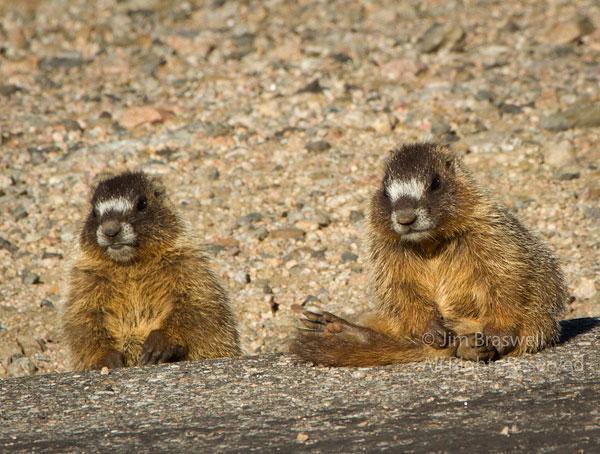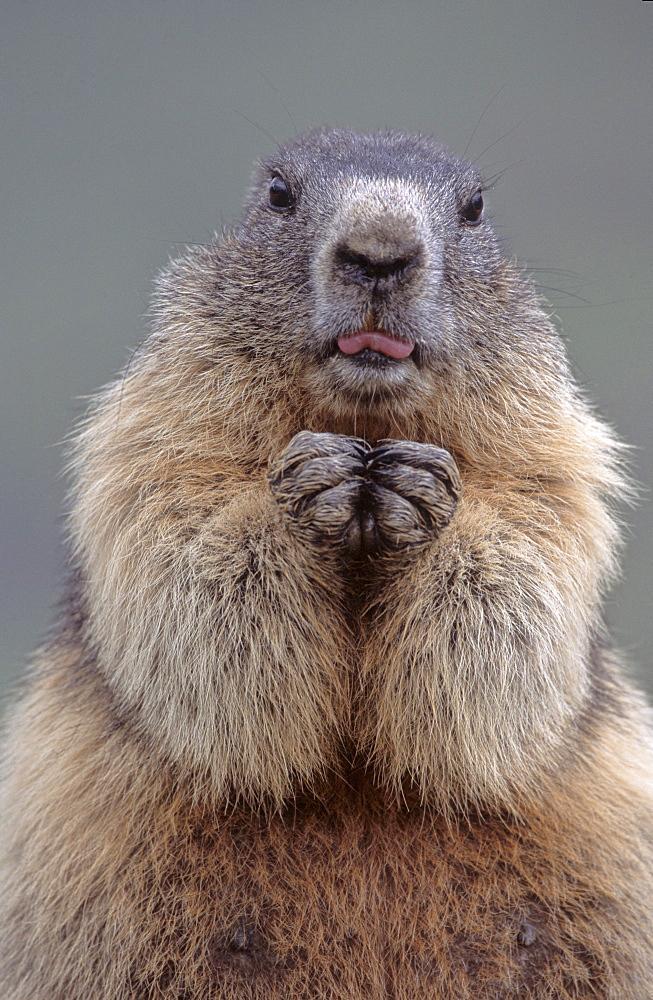The first image is the image on the left, the second image is the image on the right. For the images displayed, is the sentence "There are only 2 marmots." factually correct? Answer yes or no. No. 